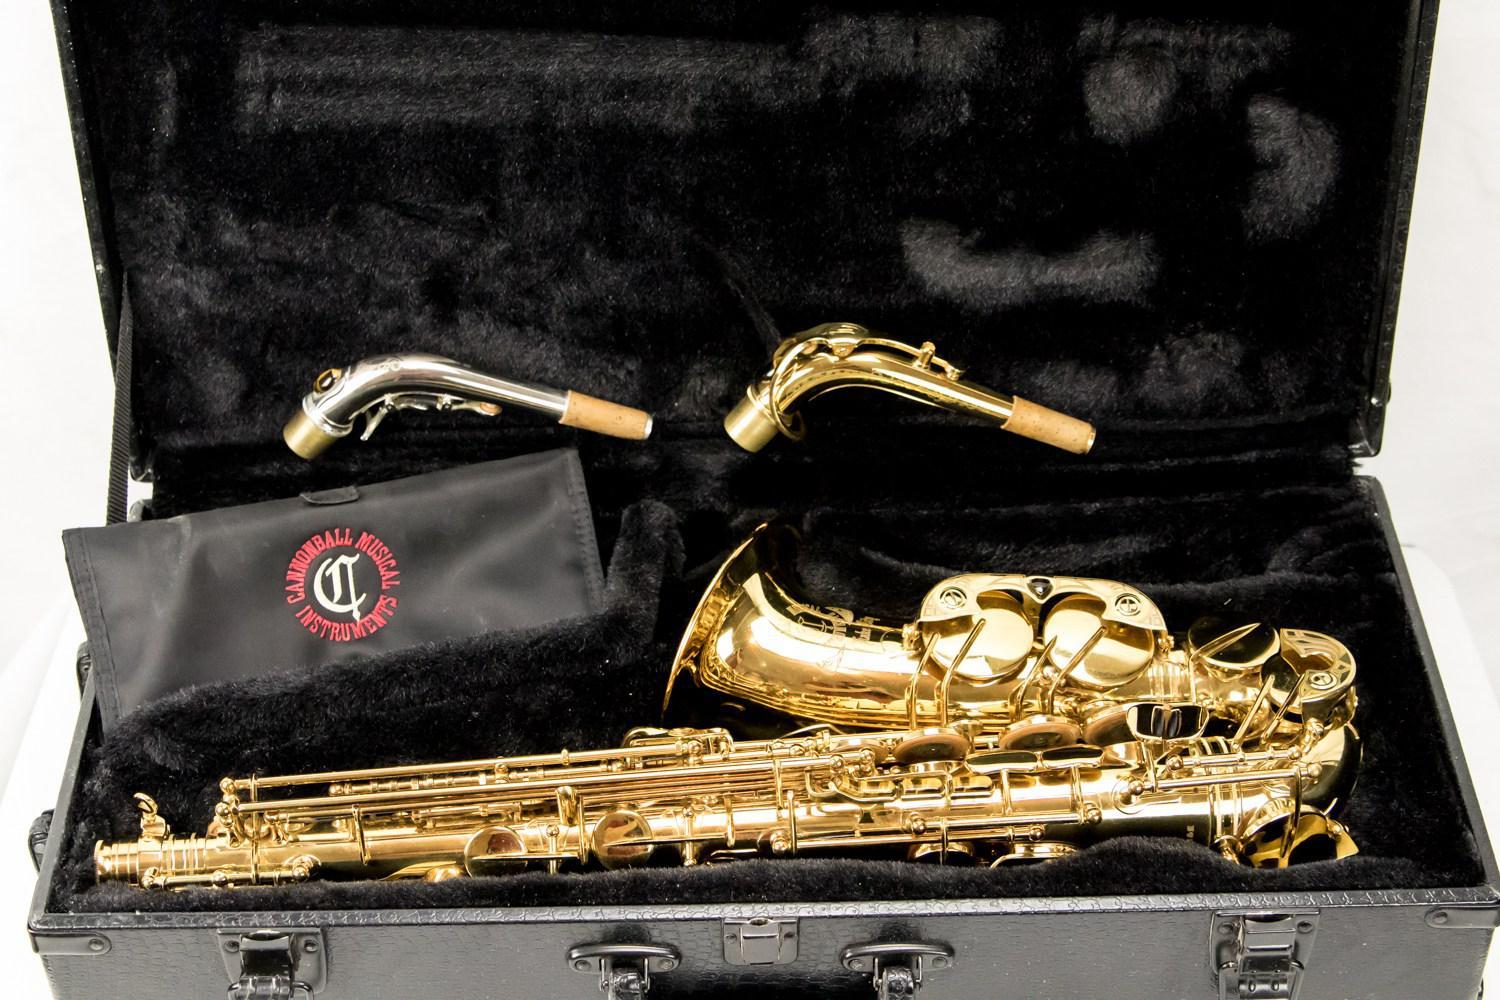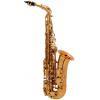The first image is the image on the left, the second image is the image on the right. Evaluate the accuracy of this statement regarding the images: "there is an instrument in its box, the box is lined in velvet and there is a bouch in the box with the instrument". Is it true? Answer yes or no. Yes. The first image is the image on the left, the second image is the image on the right. For the images shown, is this caption "One image shows a saxophone, detached mouthpieces, and a black vinyl pouch in an open case lined with black velvet." true? Answer yes or no. Yes. 